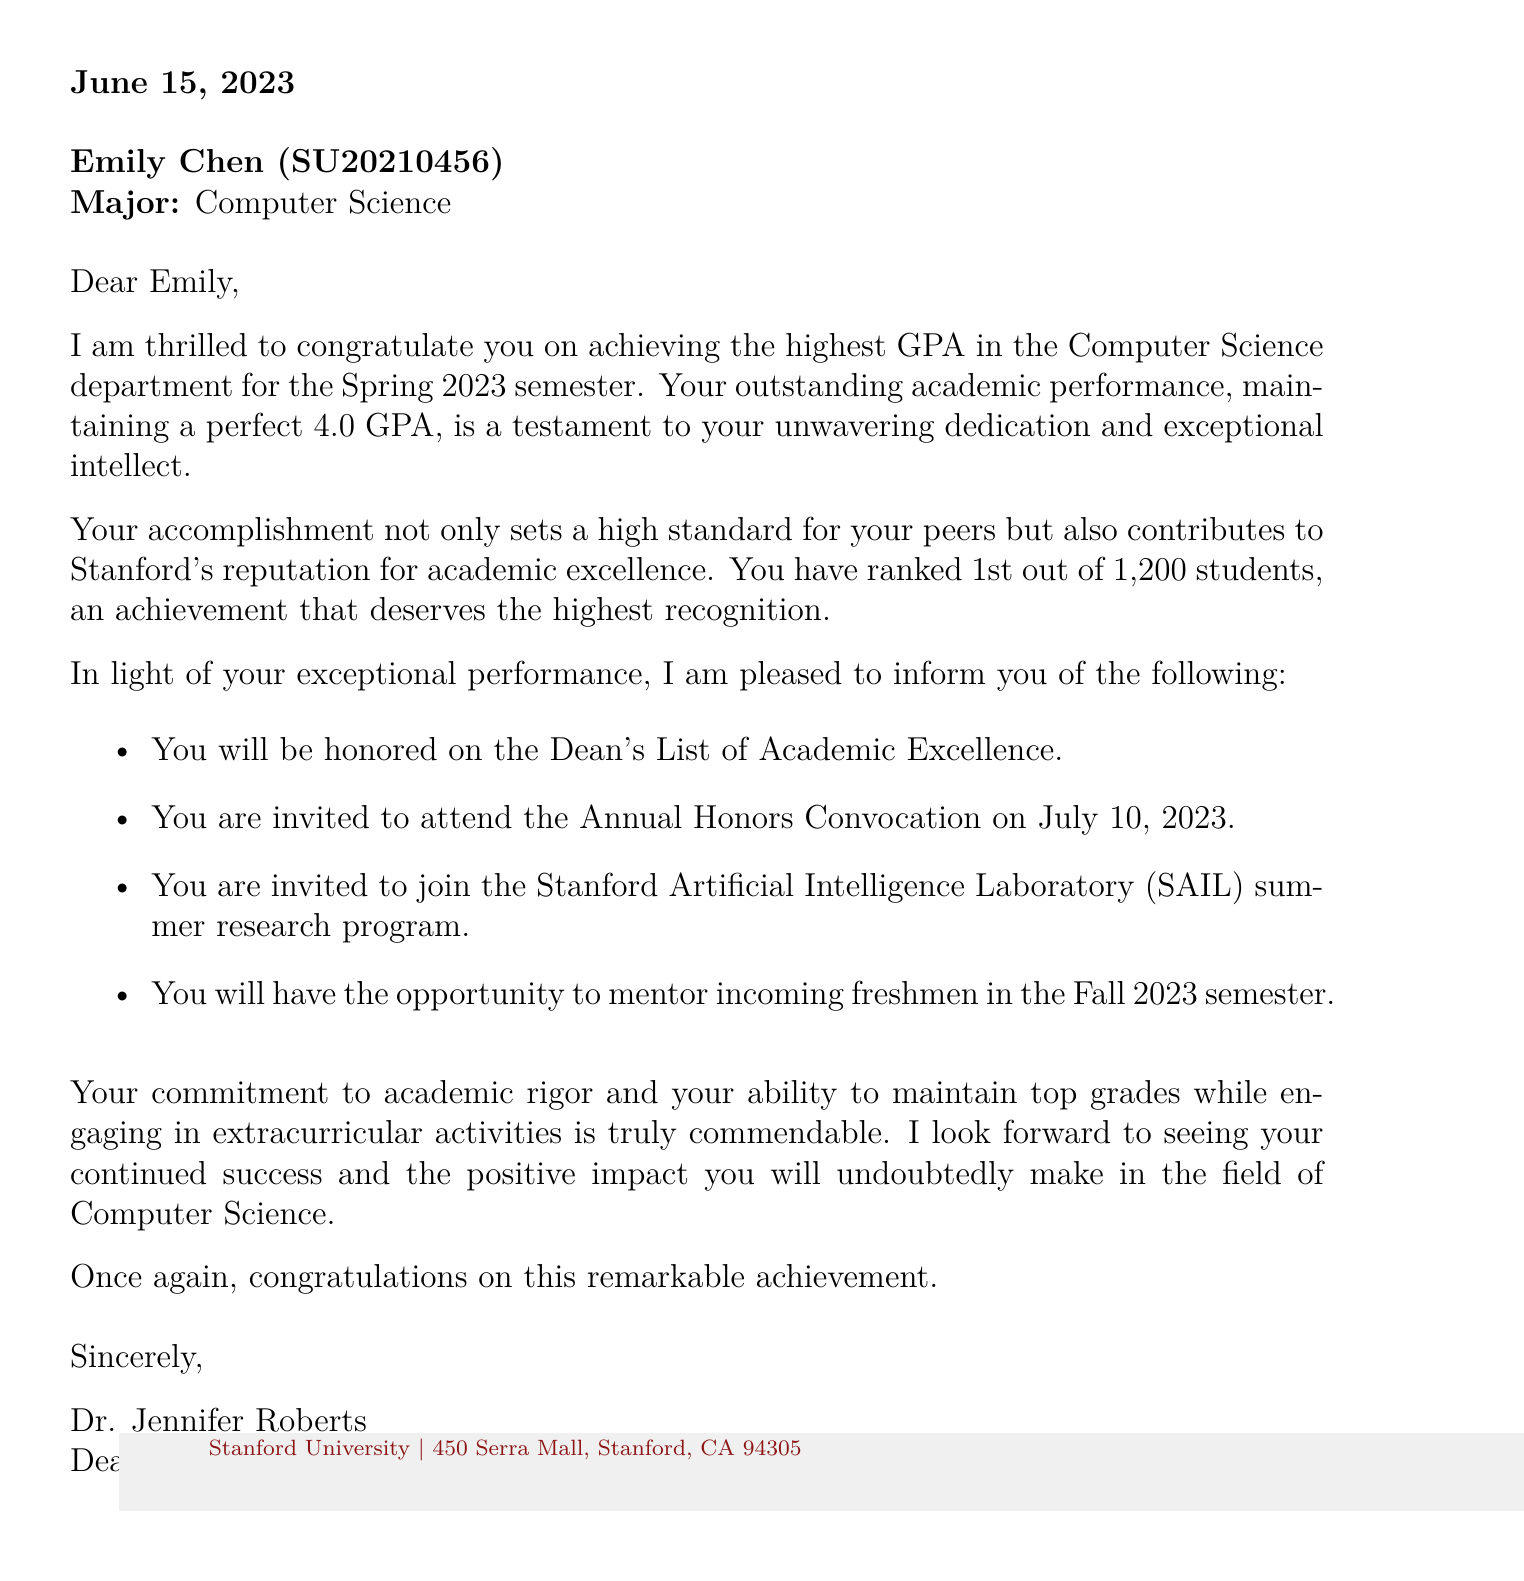What is the name of the student? The student's name is mentioned in the document as "Emily Chen."
Answer: Emily Chen What is the student's GPA? The GPA is stated in the document as a perfect score for the semester.
Answer: 4.0 When is the Annual Honors Convocation? The document specifies the date of the ceremony as July 10, 2023.
Answer: July 10, 2023 What award is the student being honored with? The document highlights that the student will be recognized on a prestigious list.
Answer: Dean's List of Academic Excellence How many students did the student rank above? The document mentions the total number of students, indicating the student's standing among them.
Answer: 1,200 students What opportunity is offered to the student for the summer? The document details a specific research program that the student is invited to join.
Answer: Stanford Artificial Intelligence Laboratory (SAIL) summer research program Who is the sender of the letter? The signature of the document reveals the name and title of the sender.
Answer: Dr. Jennifer Roberts What is the date of the letter? The document provides the specific date when the letter was written.
Answer: June 15, 2023 What major is Emily Chen pursuing? The document states the field of study that Emily is majoring in.
Answer: Computer Science 